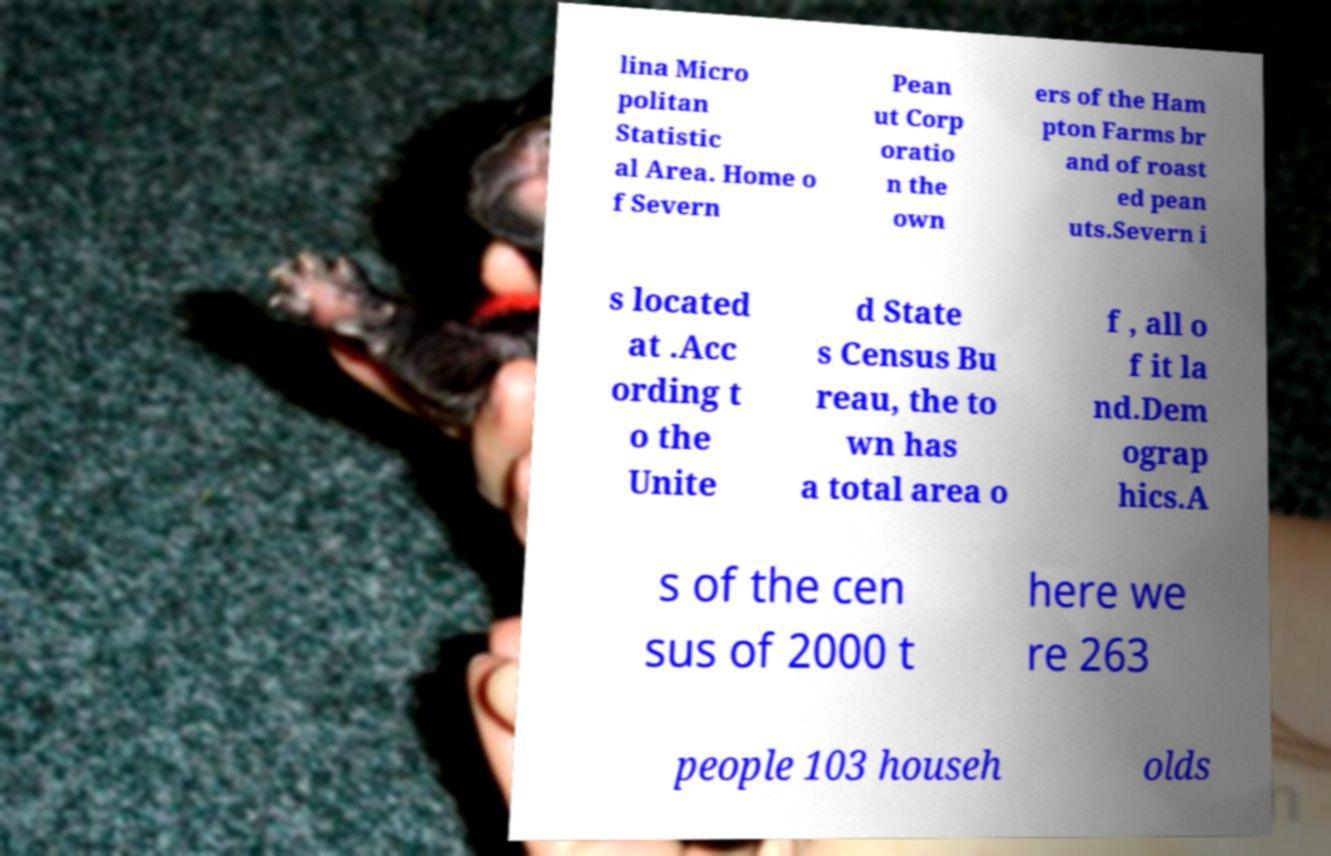Can you accurately transcribe the text from the provided image for me? lina Micro politan Statistic al Area. Home o f Severn Pean ut Corp oratio n the own ers of the Ham pton Farms br and of roast ed pean uts.Severn i s located at .Acc ording t o the Unite d State s Census Bu reau, the to wn has a total area o f , all o f it la nd.Dem ograp hics.A s of the cen sus of 2000 t here we re 263 people 103 househ olds 